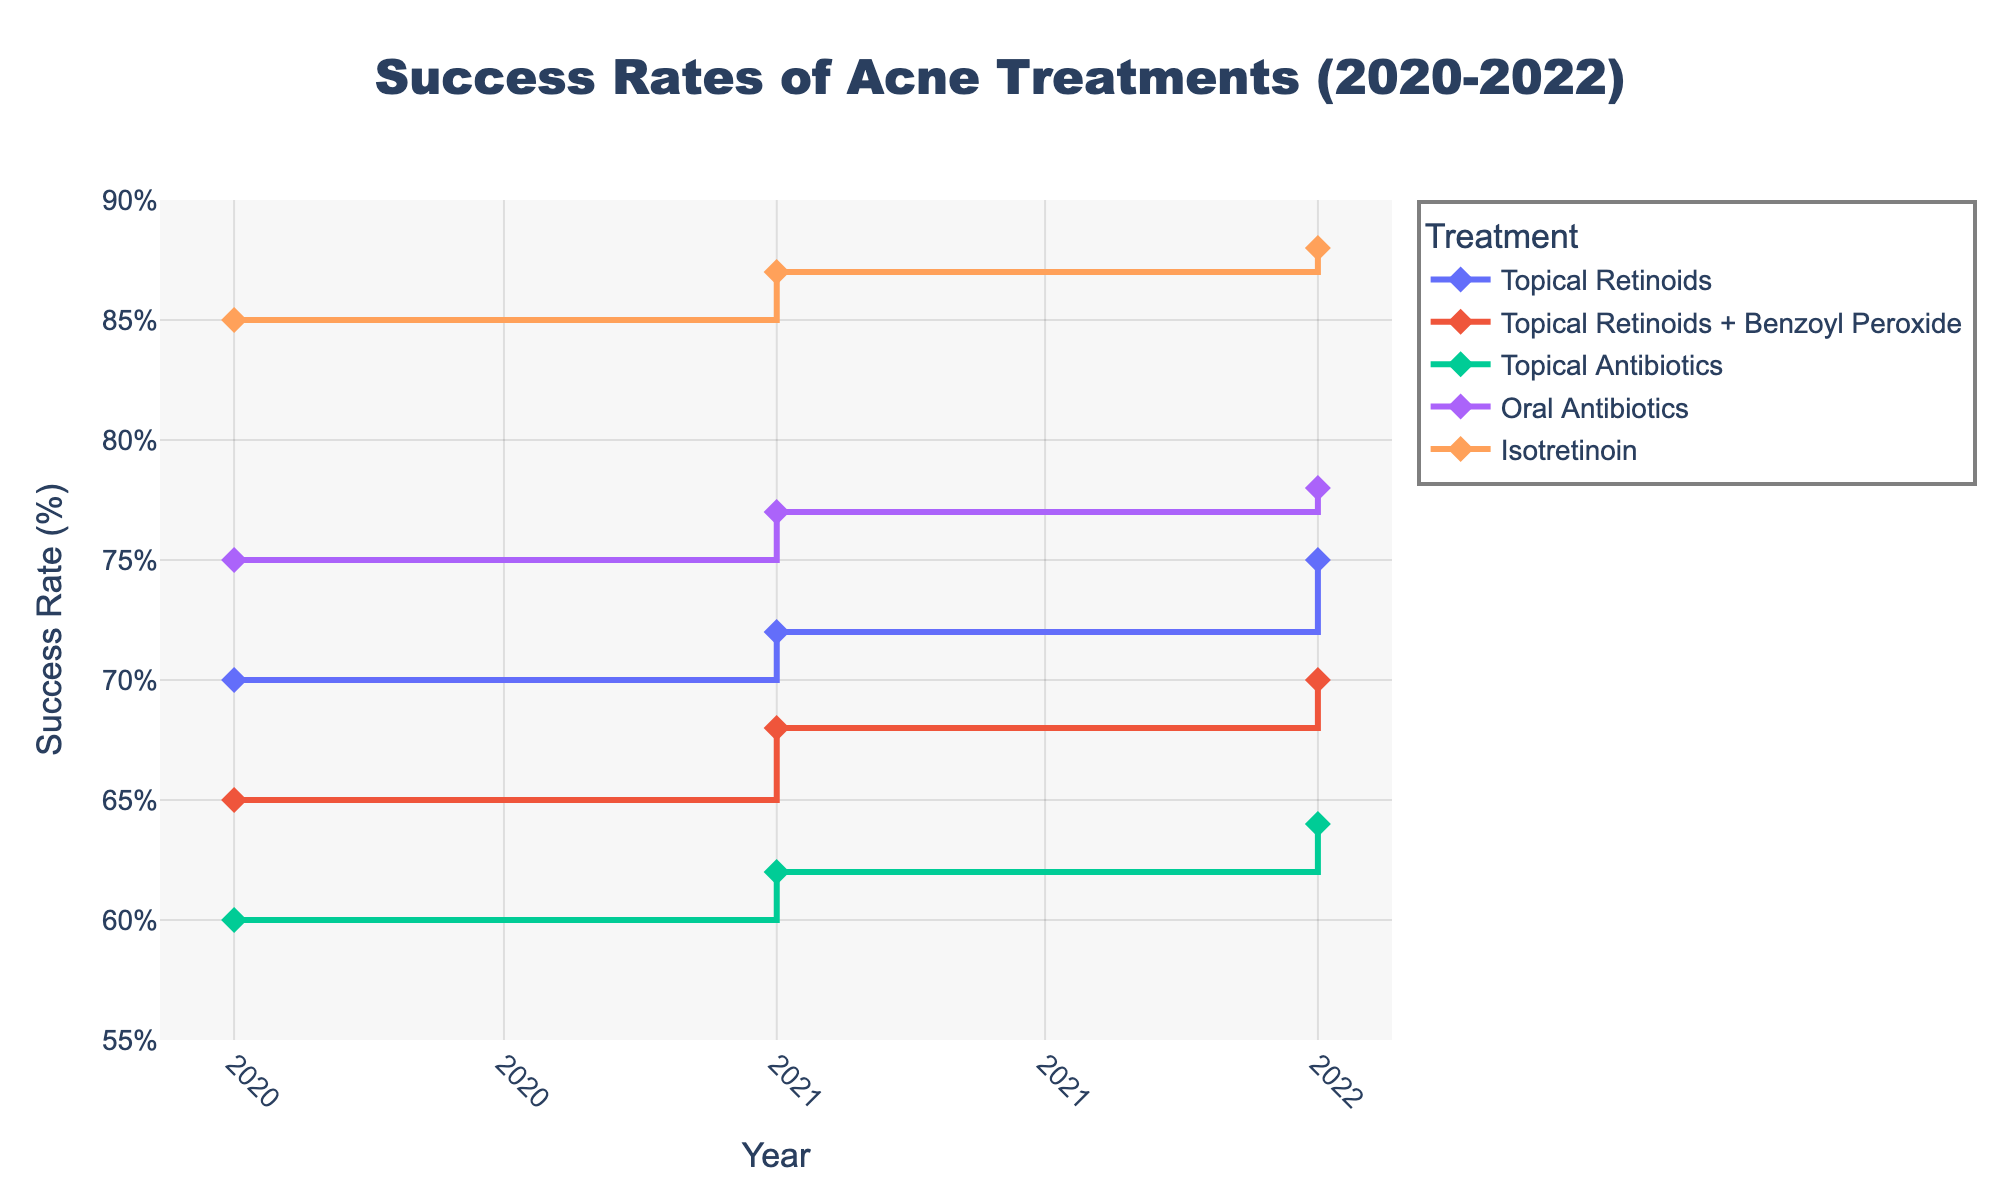What is the title of the plot? The title of the plot is usually positioned at the top center of the figure. By looking there, you can find the text of the title.
Answer: Success Rates of Acne Treatments (2020-2022) What is the success rate of Isotretinoin in 2021 for severe Inflammatory acne? To find this information, look for the Isotretinoin line in the legend, and follow it to the 2021 marker. The corresponding value on the y-axis will give the success rate.
Answer: 87% How did the success rate of Topical Retinoids for mild Comedonal acne change from 2020 to 2022? Identify the Topical Retinoids line in the legend, and observe its position at 2020 and 2022. Note the success rates at these years and compare them.
Answer: The success rate increased from 70% in 2020 to 75% in 2022 Which treatment had the highest success rate in 2022? To find this, compare the success rates for all treatments in 2022 by following the lines to their respective values at the 2022 marker. Identify the highest value.
Answer: Isotretinoin What is the range of success rates for Oral Antibiotics across all years? Identify the line representing Oral Antibiotics and note the lowest and highest values across 2020, 2021, and 2022. Subtract the smallest value from the highest to get the range.
Answer: 75% to 78% Which treatment showed a consistent increase in success rate every year for the same severity and acne type? Track the success rates for all treatments across each year. A consistent increase implies a steady upward trend without any decrease.
Answer: Topical Retinoids for mild Comedonal acne How many different treatments are shown in the plot? The different treatments can be identified by looking at the legend and counting the unique entries.
Answer: 5 Compare the success rates of Oral Antibiotics for moderate Inflammatory acne to Topical Antibiotics for mild Inflammatory acne in 2020. Locate the lines for Oral Antibiotics (moderate) and Topical Antibiotics (mild) in 2020 and note their respective success rates.
Answer: Oral Antibiotics: 75%, Topical Antibiotics: 60% What is the average success rate of Topical Retinoids + Benzoyl Peroxide treatment for moderate Comedonal acne from 2020 to 2022? Calculate the success rates for the years 2020, 2021, and 2022, add them up and divide by the number of years (3) to get the average.
Answer: (65% + 68% + 70%) / 3 = 67.67% Which severity of acne has the highest success rate overall, and which treatment achieves this? Compare the highest success rates for each severity level across different treatments and identify the highest overall value along with the corresponding treatment.
Answer: Severe Inflammatory acne, Isotretinoin 